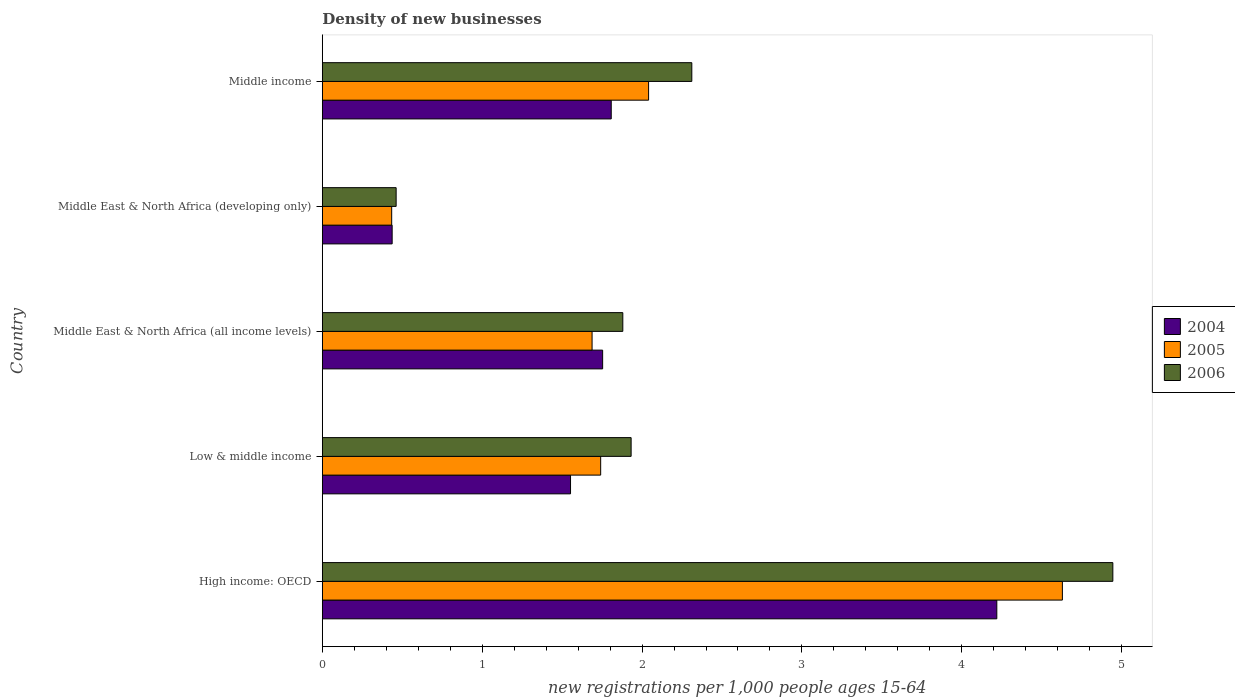How many different coloured bars are there?
Your answer should be very brief. 3. Are the number of bars per tick equal to the number of legend labels?
Your answer should be very brief. Yes. Are the number of bars on each tick of the Y-axis equal?
Your response must be concise. Yes. How many bars are there on the 1st tick from the bottom?
Provide a succinct answer. 3. What is the number of new registrations in 2006 in High income: OECD?
Make the answer very short. 4.94. Across all countries, what is the maximum number of new registrations in 2006?
Your answer should be very brief. 4.94. Across all countries, what is the minimum number of new registrations in 2005?
Your answer should be compact. 0.43. In which country was the number of new registrations in 2006 maximum?
Your answer should be compact. High income: OECD. In which country was the number of new registrations in 2005 minimum?
Provide a short and direct response. Middle East & North Africa (developing only). What is the total number of new registrations in 2004 in the graph?
Ensure brevity in your answer.  9.77. What is the difference between the number of new registrations in 2006 in Low & middle income and that in Middle East & North Africa (developing only)?
Provide a succinct answer. 1.47. What is the difference between the number of new registrations in 2004 in High income: OECD and the number of new registrations in 2005 in Low & middle income?
Offer a terse response. 2.48. What is the average number of new registrations in 2006 per country?
Offer a terse response. 2.31. What is the difference between the number of new registrations in 2004 and number of new registrations in 2006 in Middle East & North Africa (all income levels)?
Keep it short and to the point. -0.13. In how many countries, is the number of new registrations in 2005 greater than 0.6000000000000001 ?
Give a very brief answer. 4. What is the ratio of the number of new registrations in 2004 in Middle East & North Africa (all income levels) to that in Middle income?
Your response must be concise. 0.97. What is the difference between the highest and the second highest number of new registrations in 2006?
Make the answer very short. 2.63. What is the difference between the highest and the lowest number of new registrations in 2006?
Provide a short and direct response. 4.48. In how many countries, is the number of new registrations in 2004 greater than the average number of new registrations in 2004 taken over all countries?
Offer a very short reply. 1. Is the sum of the number of new registrations in 2005 in High income: OECD and Middle East & North Africa (developing only) greater than the maximum number of new registrations in 2006 across all countries?
Your answer should be compact. Yes. How many countries are there in the graph?
Ensure brevity in your answer.  5. What is the difference between two consecutive major ticks on the X-axis?
Provide a short and direct response. 1. Are the values on the major ticks of X-axis written in scientific E-notation?
Provide a succinct answer. No. Does the graph contain any zero values?
Make the answer very short. No. How many legend labels are there?
Offer a terse response. 3. What is the title of the graph?
Provide a succinct answer. Density of new businesses. What is the label or title of the X-axis?
Offer a terse response. New registrations per 1,0 people ages 15-64. What is the new registrations per 1,000 people ages 15-64 of 2004 in High income: OECD?
Your answer should be very brief. 4.22. What is the new registrations per 1,000 people ages 15-64 of 2005 in High income: OECD?
Provide a short and direct response. 4.63. What is the new registrations per 1,000 people ages 15-64 of 2006 in High income: OECD?
Offer a very short reply. 4.94. What is the new registrations per 1,000 people ages 15-64 in 2004 in Low & middle income?
Make the answer very short. 1.55. What is the new registrations per 1,000 people ages 15-64 of 2005 in Low & middle income?
Give a very brief answer. 1.74. What is the new registrations per 1,000 people ages 15-64 in 2006 in Low & middle income?
Keep it short and to the point. 1.93. What is the new registrations per 1,000 people ages 15-64 in 2004 in Middle East & North Africa (all income levels)?
Your answer should be compact. 1.75. What is the new registrations per 1,000 people ages 15-64 of 2005 in Middle East & North Africa (all income levels)?
Make the answer very short. 1.69. What is the new registrations per 1,000 people ages 15-64 of 2006 in Middle East & North Africa (all income levels)?
Your answer should be very brief. 1.88. What is the new registrations per 1,000 people ages 15-64 in 2004 in Middle East & North Africa (developing only)?
Give a very brief answer. 0.44. What is the new registrations per 1,000 people ages 15-64 in 2005 in Middle East & North Africa (developing only)?
Your response must be concise. 0.43. What is the new registrations per 1,000 people ages 15-64 in 2006 in Middle East & North Africa (developing only)?
Ensure brevity in your answer.  0.46. What is the new registrations per 1,000 people ages 15-64 in 2004 in Middle income?
Provide a succinct answer. 1.81. What is the new registrations per 1,000 people ages 15-64 in 2005 in Middle income?
Your response must be concise. 2.04. What is the new registrations per 1,000 people ages 15-64 in 2006 in Middle income?
Keep it short and to the point. 2.31. Across all countries, what is the maximum new registrations per 1,000 people ages 15-64 of 2004?
Offer a terse response. 4.22. Across all countries, what is the maximum new registrations per 1,000 people ages 15-64 in 2005?
Offer a very short reply. 4.63. Across all countries, what is the maximum new registrations per 1,000 people ages 15-64 of 2006?
Ensure brevity in your answer.  4.94. Across all countries, what is the minimum new registrations per 1,000 people ages 15-64 of 2004?
Offer a terse response. 0.44. Across all countries, what is the minimum new registrations per 1,000 people ages 15-64 in 2005?
Give a very brief answer. 0.43. Across all countries, what is the minimum new registrations per 1,000 people ages 15-64 in 2006?
Keep it short and to the point. 0.46. What is the total new registrations per 1,000 people ages 15-64 of 2004 in the graph?
Offer a very short reply. 9.77. What is the total new registrations per 1,000 people ages 15-64 in 2005 in the graph?
Keep it short and to the point. 10.53. What is the total new registrations per 1,000 people ages 15-64 of 2006 in the graph?
Offer a very short reply. 11.53. What is the difference between the new registrations per 1,000 people ages 15-64 in 2004 in High income: OECD and that in Low & middle income?
Your answer should be very brief. 2.67. What is the difference between the new registrations per 1,000 people ages 15-64 in 2005 in High income: OECD and that in Low & middle income?
Provide a short and direct response. 2.89. What is the difference between the new registrations per 1,000 people ages 15-64 in 2006 in High income: OECD and that in Low & middle income?
Provide a succinct answer. 3.01. What is the difference between the new registrations per 1,000 people ages 15-64 of 2004 in High income: OECD and that in Middle East & North Africa (all income levels)?
Ensure brevity in your answer.  2.47. What is the difference between the new registrations per 1,000 people ages 15-64 of 2005 in High income: OECD and that in Middle East & North Africa (all income levels)?
Your answer should be compact. 2.94. What is the difference between the new registrations per 1,000 people ages 15-64 in 2006 in High income: OECD and that in Middle East & North Africa (all income levels)?
Give a very brief answer. 3.07. What is the difference between the new registrations per 1,000 people ages 15-64 in 2004 in High income: OECD and that in Middle East & North Africa (developing only)?
Provide a succinct answer. 3.78. What is the difference between the new registrations per 1,000 people ages 15-64 of 2005 in High income: OECD and that in Middle East & North Africa (developing only)?
Make the answer very short. 4.2. What is the difference between the new registrations per 1,000 people ages 15-64 in 2006 in High income: OECD and that in Middle East & North Africa (developing only)?
Provide a short and direct response. 4.48. What is the difference between the new registrations per 1,000 people ages 15-64 in 2004 in High income: OECD and that in Middle income?
Provide a succinct answer. 2.41. What is the difference between the new registrations per 1,000 people ages 15-64 of 2005 in High income: OECD and that in Middle income?
Keep it short and to the point. 2.59. What is the difference between the new registrations per 1,000 people ages 15-64 in 2006 in High income: OECD and that in Middle income?
Provide a short and direct response. 2.63. What is the difference between the new registrations per 1,000 people ages 15-64 in 2004 in Low & middle income and that in Middle East & North Africa (all income levels)?
Keep it short and to the point. -0.2. What is the difference between the new registrations per 1,000 people ages 15-64 of 2005 in Low & middle income and that in Middle East & North Africa (all income levels)?
Your answer should be very brief. 0.05. What is the difference between the new registrations per 1,000 people ages 15-64 in 2006 in Low & middle income and that in Middle East & North Africa (all income levels)?
Make the answer very short. 0.05. What is the difference between the new registrations per 1,000 people ages 15-64 in 2004 in Low & middle income and that in Middle East & North Africa (developing only)?
Offer a very short reply. 1.12. What is the difference between the new registrations per 1,000 people ages 15-64 in 2005 in Low & middle income and that in Middle East & North Africa (developing only)?
Ensure brevity in your answer.  1.31. What is the difference between the new registrations per 1,000 people ages 15-64 in 2006 in Low & middle income and that in Middle East & North Africa (developing only)?
Offer a very short reply. 1.47. What is the difference between the new registrations per 1,000 people ages 15-64 of 2004 in Low & middle income and that in Middle income?
Offer a terse response. -0.25. What is the difference between the new registrations per 1,000 people ages 15-64 in 2005 in Low & middle income and that in Middle income?
Offer a very short reply. -0.3. What is the difference between the new registrations per 1,000 people ages 15-64 in 2006 in Low & middle income and that in Middle income?
Your response must be concise. -0.38. What is the difference between the new registrations per 1,000 people ages 15-64 of 2004 in Middle East & North Africa (all income levels) and that in Middle East & North Africa (developing only)?
Your response must be concise. 1.32. What is the difference between the new registrations per 1,000 people ages 15-64 of 2005 in Middle East & North Africa (all income levels) and that in Middle East & North Africa (developing only)?
Provide a short and direct response. 1.25. What is the difference between the new registrations per 1,000 people ages 15-64 in 2006 in Middle East & North Africa (all income levels) and that in Middle East & North Africa (developing only)?
Offer a terse response. 1.42. What is the difference between the new registrations per 1,000 people ages 15-64 in 2004 in Middle East & North Africa (all income levels) and that in Middle income?
Offer a terse response. -0.05. What is the difference between the new registrations per 1,000 people ages 15-64 in 2005 in Middle East & North Africa (all income levels) and that in Middle income?
Provide a short and direct response. -0.35. What is the difference between the new registrations per 1,000 people ages 15-64 in 2006 in Middle East & North Africa (all income levels) and that in Middle income?
Ensure brevity in your answer.  -0.43. What is the difference between the new registrations per 1,000 people ages 15-64 in 2004 in Middle East & North Africa (developing only) and that in Middle income?
Keep it short and to the point. -1.37. What is the difference between the new registrations per 1,000 people ages 15-64 of 2005 in Middle East & North Africa (developing only) and that in Middle income?
Provide a succinct answer. -1.61. What is the difference between the new registrations per 1,000 people ages 15-64 in 2006 in Middle East & North Africa (developing only) and that in Middle income?
Your answer should be very brief. -1.85. What is the difference between the new registrations per 1,000 people ages 15-64 in 2004 in High income: OECD and the new registrations per 1,000 people ages 15-64 in 2005 in Low & middle income?
Provide a succinct answer. 2.48. What is the difference between the new registrations per 1,000 people ages 15-64 of 2004 in High income: OECD and the new registrations per 1,000 people ages 15-64 of 2006 in Low & middle income?
Your response must be concise. 2.29. What is the difference between the new registrations per 1,000 people ages 15-64 of 2005 in High income: OECD and the new registrations per 1,000 people ages 15-64 of 2006 in Low & middle income?
Provide a short and direct response. 2.7. What is the difference between the new registrations per 1,000 people ages 15-64 in 2004 in High income: OECD and the new registrations per 1,000 people ages 15-64 in 2005 in Middle East & North Africa (all income levels)?
Offer a very short reply. 2.53. What is the difference between the new registrations per 1,000 people ages 15-64 of 2004 in High income: OECD and the new registrations per 1,000 people ages 15-64 of 2006 in Middle East & North Africa (all income levels)?
Your answer should be very brief. 2.34. What is the difference between the new registrations per 1,000 people ages 15-64 in 2005 in High income: OECD and the new registrations per 1,000 people ages 15-64 in 2006 in Middle East & North Africa (all income levels)?
Your answer should be very brief. 2.75. What is the difference between the new registrations per 1,000 people ages 15-64 in 2004 in High income: OECD and the new registrations per 1,000 people ages 15-64 in 2005 in Middle East & North Africa (developing only)?
Your answer should be compact. 3.79. What is the difference between the new registrations per 1,000 people ages 15-64 of 2004 in High income: OECD and the new registrations per 1,000 people ages 15-64 of 2006 in Middle East & North Africa (developing only)?
Your answer should be compact. 3.76. What is the difference between the new registrations per 1,000 people ages 15-64 of 2005 in High income: OECD and the new registrations per 1,000 people ages 15-64 of 2006 in Middle East & North Africa (developing only)?
Give a very brief answer. 4.17. What is the difference between the new registrations per 1,000 people ages 15-64 of 2004 in High income: OECD and the new registrations per 1,000 people ages 15-64 of 2005 in Middle income?
Your answer should be very brief. 2.18. What is the difference between the new registrations per 1,000 people ages 15-64 in 2004 in High income: OECD and the new registrations per 1,000 people ages 15-64 in 2006 in Middle income?
Provide a short and direct response. 1.91. What is the difference between the new registrations per 1,000 people ages 15-64 in 2005 in High income: OECD and the new registrations per 1,000 people ages 15-64 in 2006 in Middle income?
Provide a succinct answer. 2.32. What is the difference between the new registrations per 1,000 people ages 15-64 of 2004 in Low & middle income and the new registrations per 1,000 people ages 15-64 of 2005 in Middle East & North Africa (all income levels)?
Your response must be concise. -0.13. What is the difference between the new registrations per 1,000 people ages 15-64 in 2004 in Low & middle income and the new registrations per 1,000 people ages 15-64 in 2006 in Middle East & North Africa (all income levels)?
Your answer should be compact. -0.33. What is the difference between the new registrations per 1,000 people ages 15-64 in 2005 in Low & middle income and the new registrations per 1,000 people ages 15-64 in 2006 in Middle East & North Africa (all income levels)?
Ensure brevity in your answer.  -0.14. What is the difference between the new registrations per 1,000 people ages 15-64 of 2004 in Low & middle income and the new registrations per 1,000 people ages 15-64 of 2005 in Middle East & North Africa (developing only)?
Your response must be concise. 1.12. What is the difference between the new registrations per 1,000 people ages 15-64 in 2005 in Low & middle income and the new registrations per 1,000 people ages 15-64 in 2006 in Middle East & North Africa (developing only)?
Offer a very short reply. 1.28. What is the difference between the new registrations per 1,000 people ages 15-64 in 2004 in Low & middle income and the new registrations per 1,000 people ages 15-64 in 2005 in Middle income?
Provide a short and direct response. -0.49. What is the difference between the new registrations per 1,000 people ages 15-64 in 2004 in Low & middle income and the new registrations per 1,000 people ages 15-64 in 2006 in Middle income?
Your answer should be compact. -0.76. What is the difference between the new registrations per 1,000 people ages 15-64 of 2005 in Low & middle income and the new registrations per 1,000 people ages 15-64 of 2006 in Middle income?
Your answer should be compact. -0.57. What is the difference between the new registrations per 1,000 people ages 15-64 of 2004 in Middle East & North Africa (all income levels) and the new registrations per 1,000 people ages 15-64 of 2005 in Middle East & North Africa (developing only)?
Provide a succinct answer. 1.32. What is the difference between the new registrations per 1,000 people ages 15-64 in 2004 in Middle East & North Africa (all income levels) and the new registrations per 1,000 people ages 15-64 in 2006 in Middle East & North Africa (developing only)?
Offer a terse response. 1.29. What is the difference between the new registrations per 1,000 people ages 15-64 of 2005 in Middle East & North Africa (all income levels) and the new registrations per 1,000 people ages 15-64 of 2006 in Middle East & North Africa (developing only)?
Provide a succinct answer. 1.23. What is the difference between the new registrations per 1,000 people ages 15-64 of 2004 in Middle East & North Africa (all income levels) and the new registrations per 1,000 people ages 15-64 of 2005 in Middle income?
Offer a terse response. -0.29. What is the difference between the new registrations per 1,000 people ages 15-64 of 2004 in Middle East & North Africa (all income levels) and the new registrations per 1,000 people ages 15-64 of 2006 in Middle income?
Make the answer very short. -0.56. What is the difference between the new registrations per 1,000 people ages 15-64 in 2005 in Middle East & North Africa (all income levels) and the new registrations per 1,000 people ages 15-64 in 2006 in Middle income?
Give a very brief answer. -0.62. What is the difference between the new registrations per 1,000 people ages 15-64 in 2004 in Middle East & North Africa (developing only) and the new registrations per 1,000 people ages 15-64 in 2005 in Middle income?
Make the answer very short. -1.6. What is the difference between the new registrations per 1,000 people ages 15-64 in 2004 in Middle East & North Africa (developing only) and the new registrations per 1,000 people ages 15-64 in 2006 in Middle income?
Give a very brief answer. -1.87. What is the difference between the new registrations per 1,000 people ages 15-64 in 2005 in Middle East & North Africa (developing only) and the new registrations per 1,000 people ages 15-64 in 2006 in Middle income?
Make the answer very short. -1.88. What is the average new registrations per 1,000 people ages 15-64 in 2004 per country?
Make the answer very short. 1.95. What is the average new registrations per 1,000 people ages 15-64 of 2005 per country?
Your answer should be compact. 2.11. What is the average new registrations per 1,000 people ages 15-64 in 2006 per country?
Offer a terse response. 2.31. What is the difference between the new registrations per 1,000 people ages 15-64 in 2004 and new registrations per 1,000 people ages 15-64 in 2005 in High income: OECD?
Your response must be concise. -0.41. What is the difference between the new registrations per 1,000 people ages 15-64 of 2004 and new registrations per 1,000 people ages 15-64 of 2006 in High income: OECD?
Your answer should be very brief. -0.73. What is the difference between the new registrations per 1,000 people ages 15-64 in 2005 and new registrations per 1,000 people ages 15-64 in 2006 in High income: OECD?
Offer a terse response. -0.32. What is the difference between the new registrations per 1,000 people ages 15-64 of 2004 and new registrations per 1,000 people ages 15-64 of 2005 in Low & middle income?
Give a very brief answer. -0.19. What is the difference between the new registrations per 1,000 people ages 15-64 in 2004 and new registrations per 1,000 people ages 15-64 in 2006 in Low & middle income?
Keep it short and to the point. -0.38. What is the difference between the new registrations per 1,000 people ages 15-64 in 2005 and new registrations per 1,000 people ages 15-64 in 2006 in Low & middle income?
Provide a short and direct response. -0.19. What is the difference between the new registrations per 1,000 people ages 15-64 in 2004 and new registrations per 1,000 people ages 15-64 in 2005 in Middle East & North Africa (all income levels)?
Ensure brevity in your answer.  0.07. What is the difference between the new registrations per 1,000 people ages 15-64 of 2004 and new registrations per 1,000 people ages 15-64 of 2006 in Middle East & North Africa (all income levels)?
Make the answer very short. -0.13. What is the difference between the new registrations per 1,000 people ages 15-64 in 2005 and new registrations per 1,000 people ages 15-64 in 2006 in Middle East & North Africa (all income levels)?
Offer a terse response. -0.19. What is the difference between the new registrations per 1,000 people ages 15-64 of 2004 and new registrations per 1,000 people ages 15-64 of 2005 in Middle East & North Africa (developing only)?
Your answer should be very brief. 0. What is the difference between the new registrations per 1,000 people ages 15-64 of 2004 and new registrations per 1,000 people ages 15-64 of 2006 in Middle East & North Africa (developing only)?
Your answer should be very brief. -0.02. What is the difference between the new registrations per 1,000 people ages 15-64 in 2005 and new registrations per 1,000 people ages 15-64 in 2006 in Middle East & North Africa (developing only)?
Ensure brevity in your answer.  -0.03. What is the difference between the new registrations per 1,000 people ages 15-64 of 2004 and new registrations per 1,000 people ages 15-64 of 2005 in Middle income?
Give a very brief answer. -0.23. What is the difference between the new registrations per 1,000 people ages 15-64 in 2004 and new registrations per 1,000 people ages 15-64 in 2006 in Middle income?
Offer a very short reply. -0.5. What is the difference between the new registrations per 1,000 people ages 15-64 in 2005 and new registrations per 1,000 people ages 15-64 in 2006 in Middle income?
Offer a very short reply. -0.27. What is the ratio of the new registrations per 1,000 people ages 15-64 of 2004 in High income: OECD to that in Low & middle income?
Provide a succinct answer. 2.72. What is the ratio of the new registrations per 1,000 people ages 15-64 in 2005 in High income: OECD to that in Low & middle income?
Your answer should be compact. 2.66. What is the ratio of the new registrations per 1,000 people ages 15-64 of 2006 in High income: OECD to that in Low & middle income?
Make the answer very short. 2.56. What is the ratio of the new registrations per 1,000 people ages 15-64 in 2004 in High income: OECD to that in Middle East & North Africa (all income levels)?
Ensure brevity in your answer.  2.41. What is the ratio of the new registrations per 1,000 people ages 15-64 in 2005 in High income: OECD to that in Middle East & North Africa (all income levels)?
Your response must be concise. 2.74. What is the ratio of the new registrations per 1,000 people ages 15-64 in 2006 in High income: OECD to that in Middle East & North Africa (all income levels)?
Keep it short and to the point. 2.63. What is the ratio of the new registrations per 1,000 people ages 15-64 of 2004 in High income: OECD to that in Middle East & North Africa (developing only)?
Your answer should be compact. 9.66. What is the ratio of the new registrations per 1,000 people ages 15-64 in 2005 in High income: OECD to that in Middle East & North Africa (developing only)?
Your answer should be very brief. 10.67. What is the ratio of the new registrations per 1,000 people ages 15-64 of 2006 in High income: OECD to that in Middle East & North Africa (developing only)?
Your response must be concise. 10.71. What is the ratio of the new registrations per 1,000 people ages 15-64 in 2004 in High income: OECD to that in Middle income?
Your answer should be very brief. 2.33. What is the ratio of the new registrations per 1,000 people ages 15-64 in 2005 in High income: OECD to that in Middle income?
Your response must be concise. 2.27. What is the ratio of the new registrations per 1,000 people ages 15-64 in 2006 in High income: OECD to that in Middle income?
Offer a very short reply. 2.14. What is the ratio of the new registrations per 1,000 people ages 15-64 of 2004 in Low & middle income to that in Middle East & North Africa (all income levels)?
Keep it short and to the point. 0.89. What is the ratio of the new registrations per 1,000 people ages 15-64 in 2005 in Low & middle income to that in Middle East & North Africa (all income levels)?
Your answer should be compact. 1.03. What is the ratio of the new registrations per 1,000 people ages 15-64 in 2006 in Low & middle income to that in Middle East & North Africa (all income levels)?
Provide a succinct answer. 1.03. What is the ratio of the new registrations per 1,000 people ages 15-64 in 2004 in Low & middle income to that in Middle East & North Africa (developing only)?
Offer a terse response. 3.55. What is the ratio of the new registrations per 1,000 people ages 15-64 of 2005 in Low & middle income to that in Middle East & North Africa (developing only)?
Keep it short and to the point. 4.01. What is the ratio of the new registrations per 1,000 people ages 15-64 in 2006 in Low & middle income to that in Middle East & North Africa (developing only)?
Provide a succinct answer. 4.18. What is the ratio of the new registrations per 1,000 people ages 15-64 of 2004 in Low & middle income to that in Middle income?
Your answer should be very brief. 0.86. What is the ratio of the new registrations per 1,000 people ages 15-64 of 2005 in Low & middle income to that in Middle income?
Your response must be concise. 0.85. What is the ratio of the new registrations per 1,000 people ages 15-64 in 2006 in Low & middle income to that in Middle income?
Offer a terse response. 0.84. What is the ratio of the new registrations per 1,000 people ages 15-64 in 2004 in Middle East & North Africa (all income levels) to that in Middle East & North Africa (developing only)?
Keep it short and to the point. 4.01. What is the ratio of the new registrations per 1,000 people ages 15-64 in 2005 in Middle East & North Africa (all income levels) to that in Middle East & North Africa (developing only)?
Your response must be concise. 3.89. What is the ratio of the new registrations per 1,000 people ages 15-64 of 2006 in Middle East & North Africa (all income levels) to that in Middle East & North Africa (developing only)?
Your response must be concise. 4.07. What is the ratio of the new registrations per 1,000 people ages 15-64 of 2004 in Middle East & North Africa (all income levels) to that in Middle income?
Your answer should be compact. 0.97. What is the ratio of the new registrations per 1,000 people ages 15-64 in 2005 in Middle East & North Africa (all income levels) to that in Middle income?
Provide a succinct answer. 0.83. What is the ratio of the new registrations per 1,000 people ages 15-64 in 2006 in Middle East & North Africa (all income levels) to that in Middle income?
Offer a very short reply. 0.81. What is the ratio of the new registrations per 1,000 people ages 15-64 in 2004 in Middle East & North Africa (developing only) to that in Middle income?
Offer a terse response. 0.24. What is the ratio of the new registrations per 1,000 people ages 15-64 in 2005 in Middle East & North Africa (developing only) to that in Middle income?
Offer a very short reply. 0.21. What is the ratio of the new registrations per 1,000 people ages 15-64 in 2006 in Middle East & North Africa (developing only) to that in Middle income?
Offer a very short reply. 0.2. What is the difference between the highest and the second highest new registrations per 1,000 people ages 15-64 in 2004?
Ensure brevity in your answer.  2.41. What is the difference between the highest and the second highest new registrations per 1,000 people ages 15-64 in 2005?
Your answer should be compact. 2.59. What is the difference between the highest and the second highest new registrations per 1,000 people ages 15-64 of 2006?
Give a very brief answer. 2.63. What is the difference between the highest and the lowest new registrations per 1,000 people ages 15-64 in 2004?
Offer a very short reply. 3.78. What is the difference between the highest and the lowest new registrations per 1,000 people ages 15-64 in 2005?
Offer a very short reply. 4.2. What is the difference between the highest and the lowest new registrations per 1,000 people ages 15-64 in 2006?
Offer a very short reply. 4.48. 